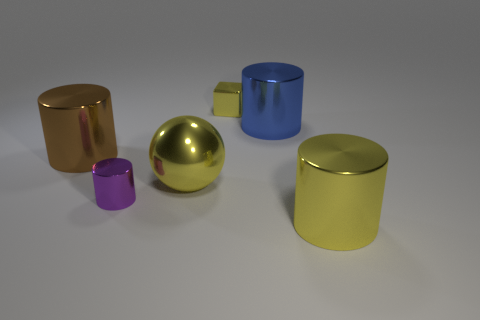There is a large object that is both left of the large blue shiny cylinder and in front of the brown object; what is its color?
Your response must be concise. Yellow. There is a cylinder behind the brown thing; is its size the same as the metal cylinder left of the small purple metallic cylinder?
Offer a terse response. Yes. How many large cylinders have the same color as the metal sphere?
Offer a very short reply. 1. What number of small objects are either metallic objects or brown cylinders?
Keep it short and to the point. 2. Is the tiny object behind the ball made of the same material as the large brown object?
Give a very brief answer. Yes. What is the color of the big metal object that is behind the brown metal cylinder?
Give a very brief answer. Blue. Are there any other cylinders that have the same size as the brown cylinder?
Offer a very short reply. Yes. What material is the purple thing that is the same size as the metallic block?
Ensure brevity in your answer.  Metal. There is a sphere; is it the same size as the purple metal cylinder that is on the left side of the yellow metal block?
Provide a succinct answer. No. Are there the same number of small purple metallic objects that are behind the brown shiny thing and brown rubber cubes?
Provide a short and direct response. Yes. 